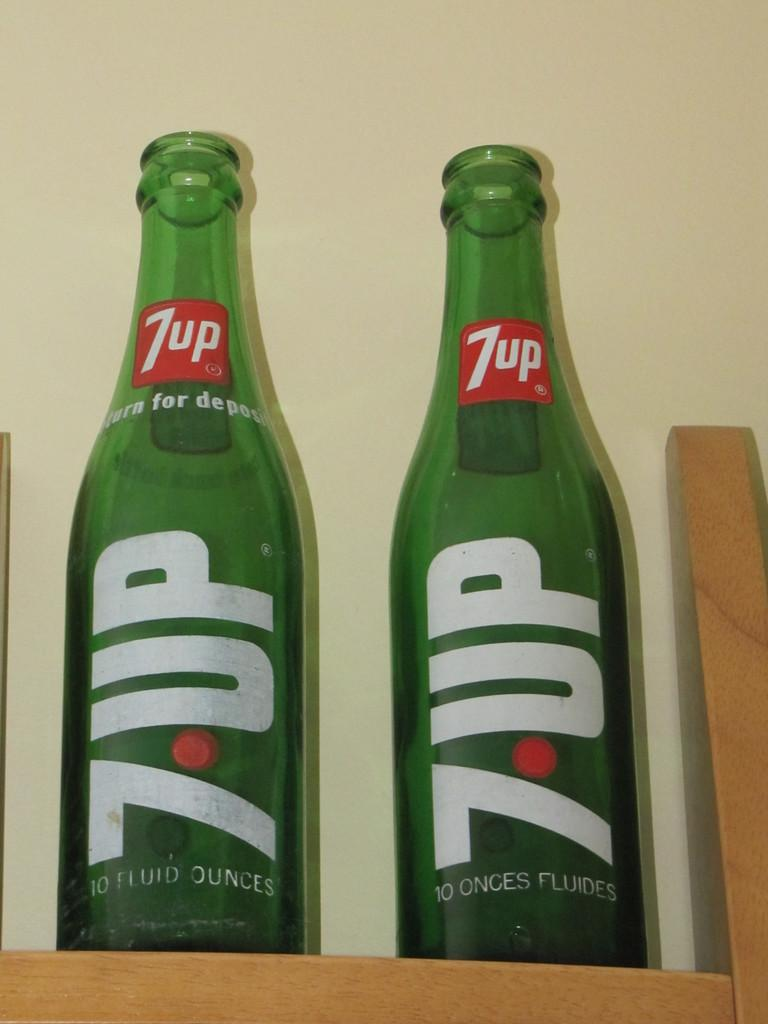<image>
Provide a brief description of the given image. Two bottles of "7 UP" are next to each other. 